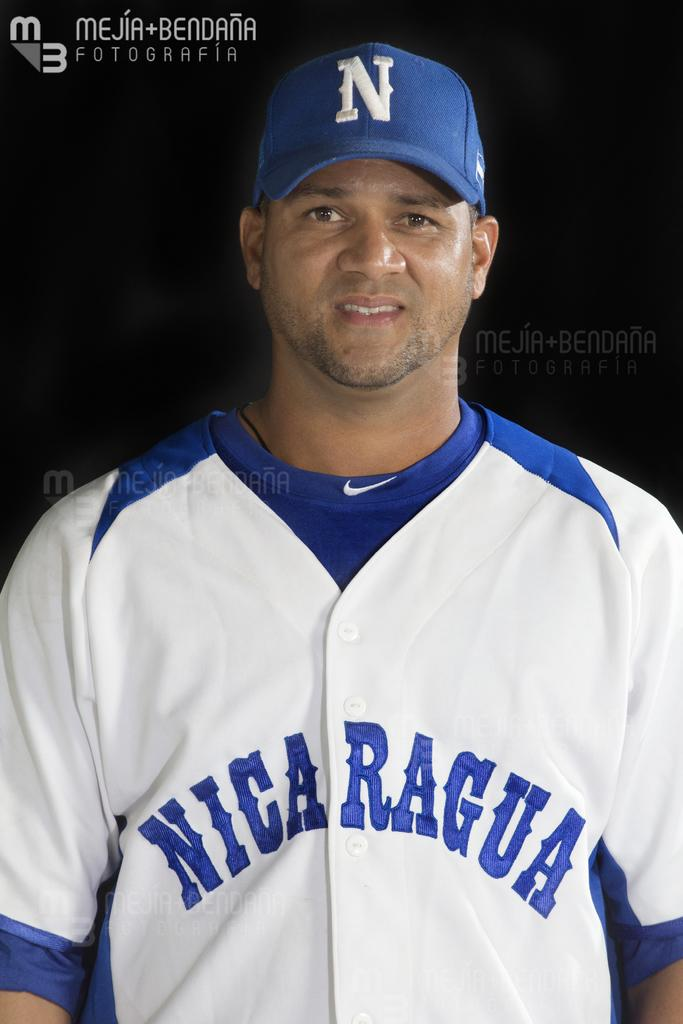<image>
Render a clear and concise summary of the photo. A Nicaraguan baseball player got his picture taken at Mejia + Bendana. 